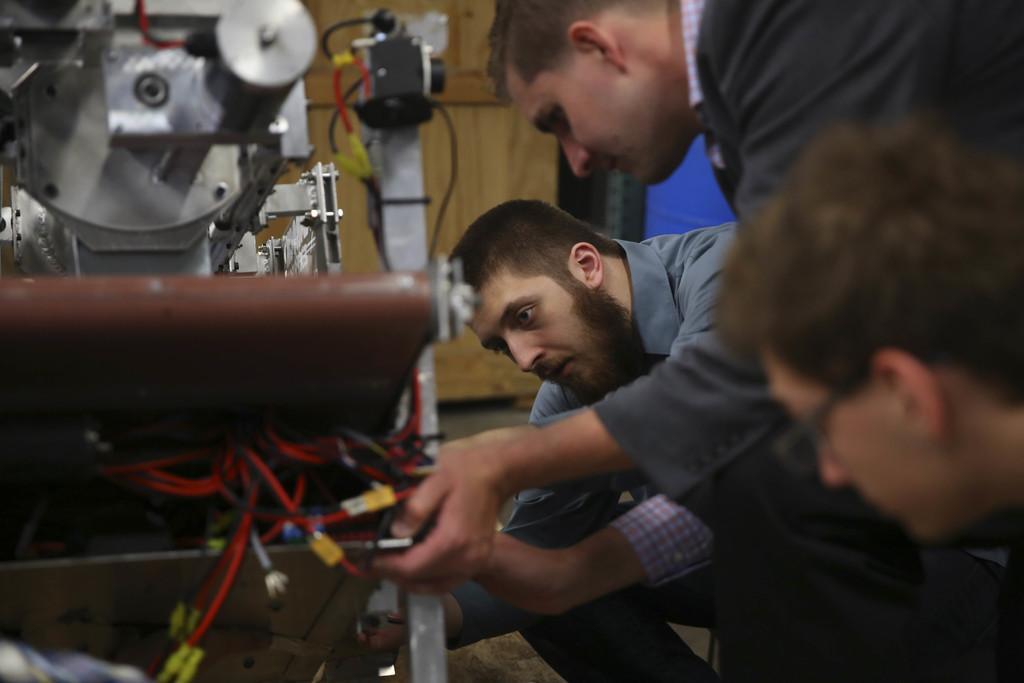Could you give a brief overview of what you see in this image? In this picture we can see few people, in front of them we can find a machine and cables. 